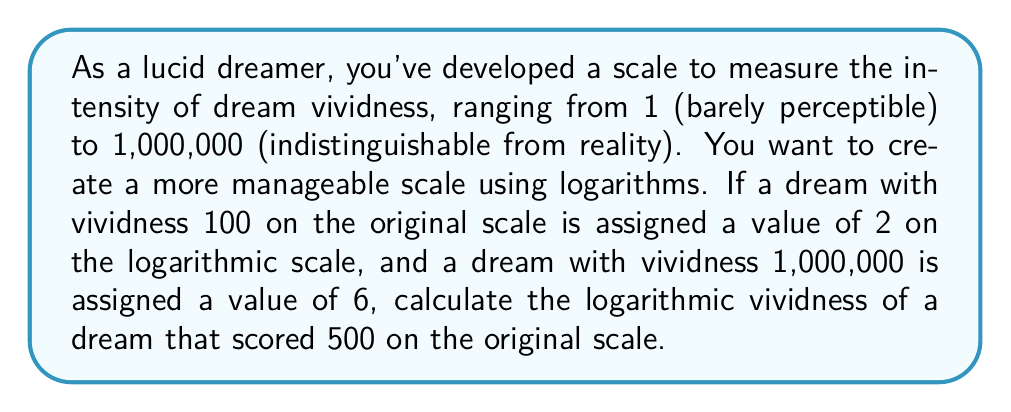Help me with this question. Let's approach this step-by-step:

1) We're creating a logarithmic scale, so we can assume the form:

   $y = a \log_{b}(x) + c$

   where $y$ is the logarithmic scale value, $x$ is the original scale value, and $a$, $b$, and $c$ are constants we need to determine.

2) We have two known points:
   $(100, 2)$ and $(1,000,000, 6)$

3) Let's substitute these into our equation:

   $2 = a \log_{b}(100) + c$
   $6 = a \log_{b}(1,000,000) + c$

4) Subtracting these equations:

   $4 = a (\log_{b}(1,000,000) - \log_{b}(100))$
   $4 = a (\log_{b}(10,000))$
   $4 = a (4 \log_{b}(10))$

5) We can simplify this if we choose $b = 10$:

   $4 = 4a$
   $a = 1$

6) Now we can find $c$ using either of our original equations:

   $2 = \log_{10}(100) + c$
   $2 = 2 + c$
   $c = 0$

7) So our logarithmic scale is:

   $y = \log_{10}(x)$

8) For a dream with vividness 500 on the original scale:

   $y = \log_{10}(500)$
   $y = 2.69897...$
Answer: The logarithmic vividness of a dream that scored 500 on the original scale is approximately 2.69897. 